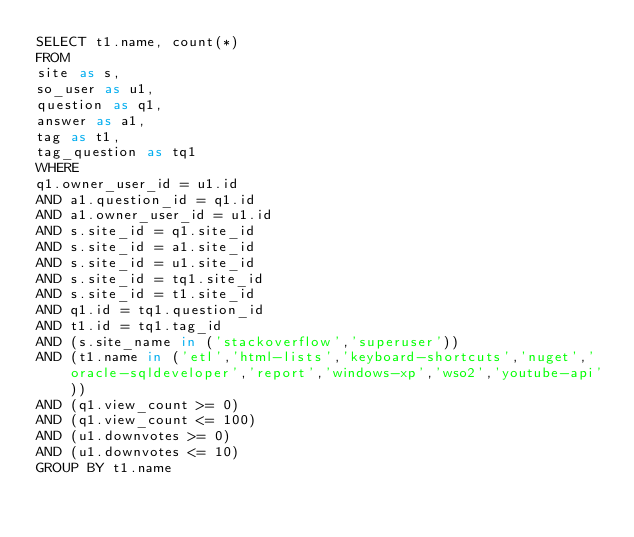Convert code to text. <code><loc_0><loc_0><loc_500><loc_500><_SQL_>SELECT t1.name, count(*)
FROM
site as s,
so_user as u1,
question as q1,
answer as a1,
tag as t1,
tag_question as tq1
WHERE
q1.owner_user_id = u1.id
AND a1.question_id = q1.id
AND a1.owner_user_id = u1.id
AND s.site_id = q1.site_id
AND s.site_id = a1.site_id
AND s.site_id = u1.site_id
AND s.site_id = tq1.site_id
AND s.site_id = t1.site_id
AND q1.id = tq1.question_id
AND t1.id = tq1.tag_id
AND (s.site_name in ('stackoverflow','superuser'))
AND (t1.name in ('etl','html-lists','keyboard-shortcuts','nuget','oracle-sqldeveloper','report','windows-xp','wso2','youtube-api'))
AND (q1.view_count >= 0)
AND (q1.view_count <= 100)
AND (u1.downvotes >= 0)
AND (u1.downvotes <= 10)
GROUP BY t1.name</code> 